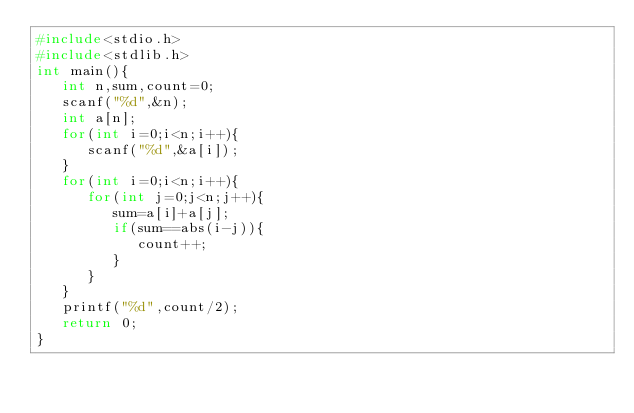Convert code to text. <code><loc_0><loc_0><loc_500><loc_500><_C_>#include<stdio.h>
#include<stdlib.h>
int main(){
   int n,sum,count=0;
   scanf("%d",&n);
   int a[n];
   for(int i=0;i<n;i++){
      scanf("%d",&a[i]);
   }
   for(int i=0;i<n;i++){
      for(int j=0;j<n;j++){
         sum=a[i]+a[j];
         if(sum==abs(i-j)){
            count++;
         }
      }
   }
   printf("%d",count/2);
   return 0;
}
</code> 